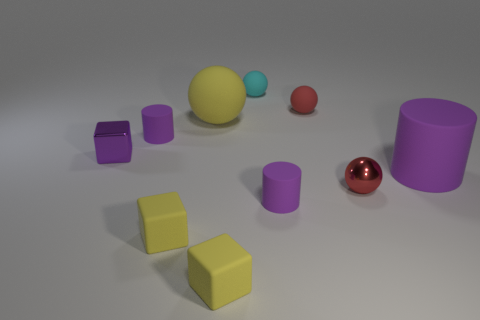How many purple cylinders must be subtracted to get 1 purple cylinders? 2 Subtract 1 balls. How many balls are left? 3 Subtract all purple balls. Subtract all gray cubes. How many balls are left? 4 Subtract all cylinders. How many objects are left? 7 Add 7 red rubber objects. How many red rubber objects exist? 8 Subtract 1 yellow cubes. How many objects are left? 9 Subtract all tiny blue shiny spheres. Subtract all tiny yellow cubes. How many objects are left? 8 Add 7 tiny matte cylinders. How many tiny matte cylinders are left? 9 